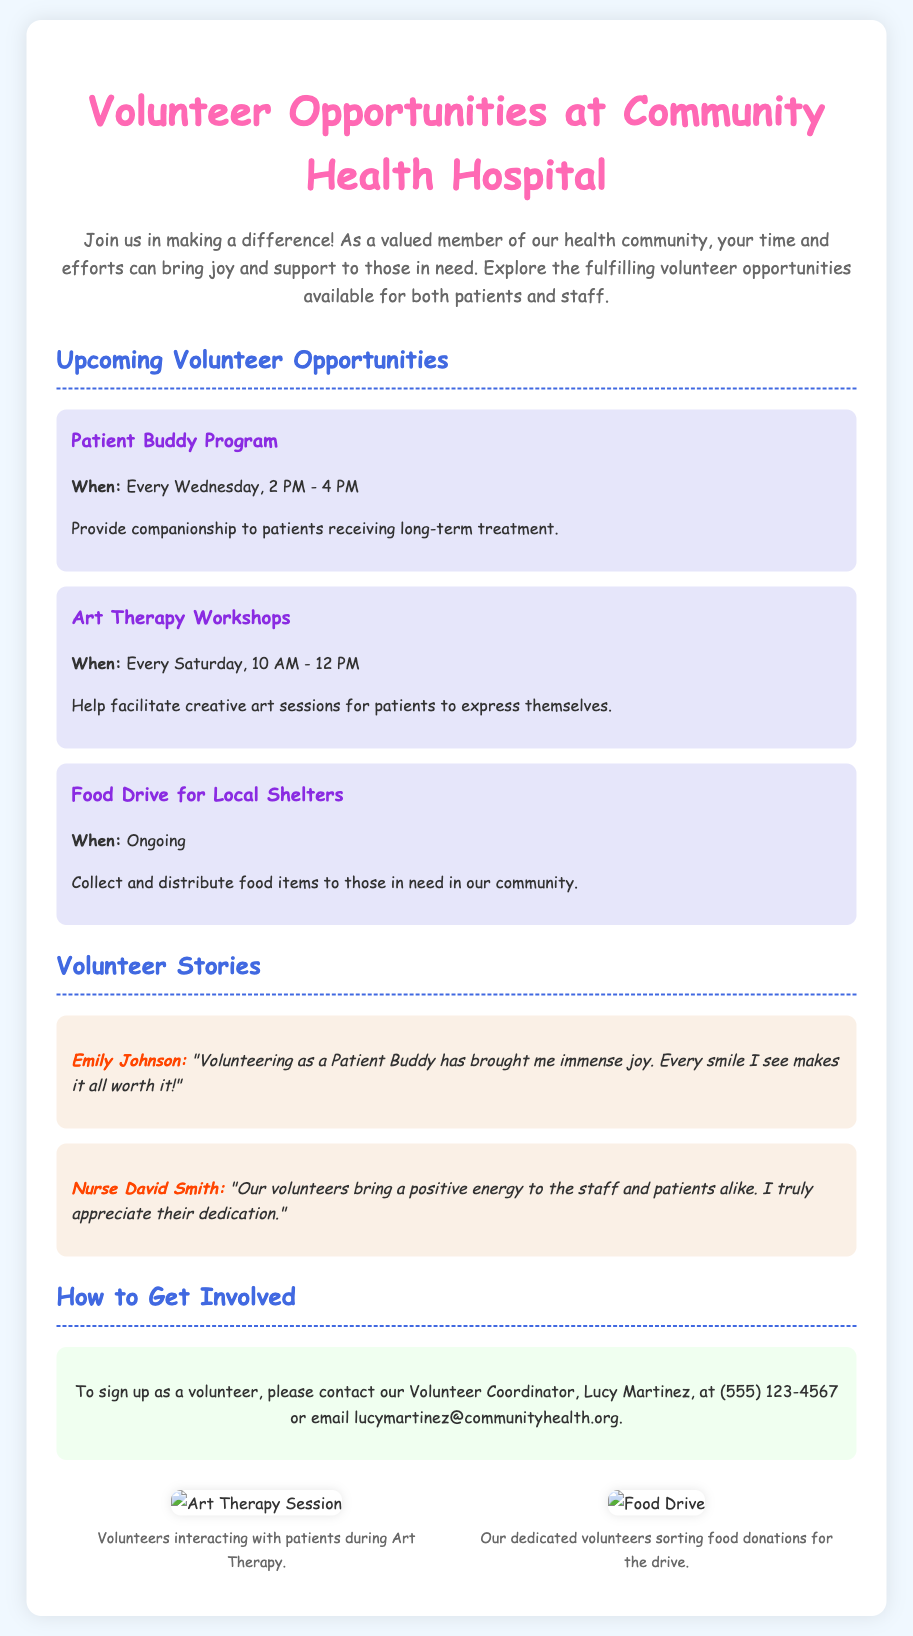What is the title of the brochure? The title is prominently displayed at the top of the document, which is "Volunteer Opportunities at Community Health Hospital."
Answer: Volunteer Opportunities at Community Health Hospital Who is the Volunteer Coordinator? The document mentions Lucy Martinez as the person to contact for volunteering inquiries.
Answer: Lucy Martinez When does the Patient Buddy Program take place? The specific time for the Patient Buddy Program is stated in the document as occurring every Wednesday from 2 PM to 4 PM.
Answer: Every Wednesday, 2 PM - 4 PM What type of workshop is held every Saturday? The document lists "Art Therapy Workshops" as the activity that takes place each Saturday.
Answer: Art Therapy Workshops What can volunteers assist with during Art Therapy Workshops? It explains that volunteers help facilitate creative art sessions for patients.
Answer: Facilitate creative art sessions How often is the Food Drive for Local Shelters held? The document specifically states that this opportunity is ongoing, which means it occurs continuously without a set end date.
Answer: Ongoing Who shared a positive experience about volunteering? The document includes a quote from Nurse David Smith about the impact of volunteers.
Answer: Nurse David Smith What is the main theme of the photos included in the brochure? The photos illustrate the active engagement of volunteers in events like Art Therapy and food sorting, highlighting their involvement.
Answer: Volunteer involvement 